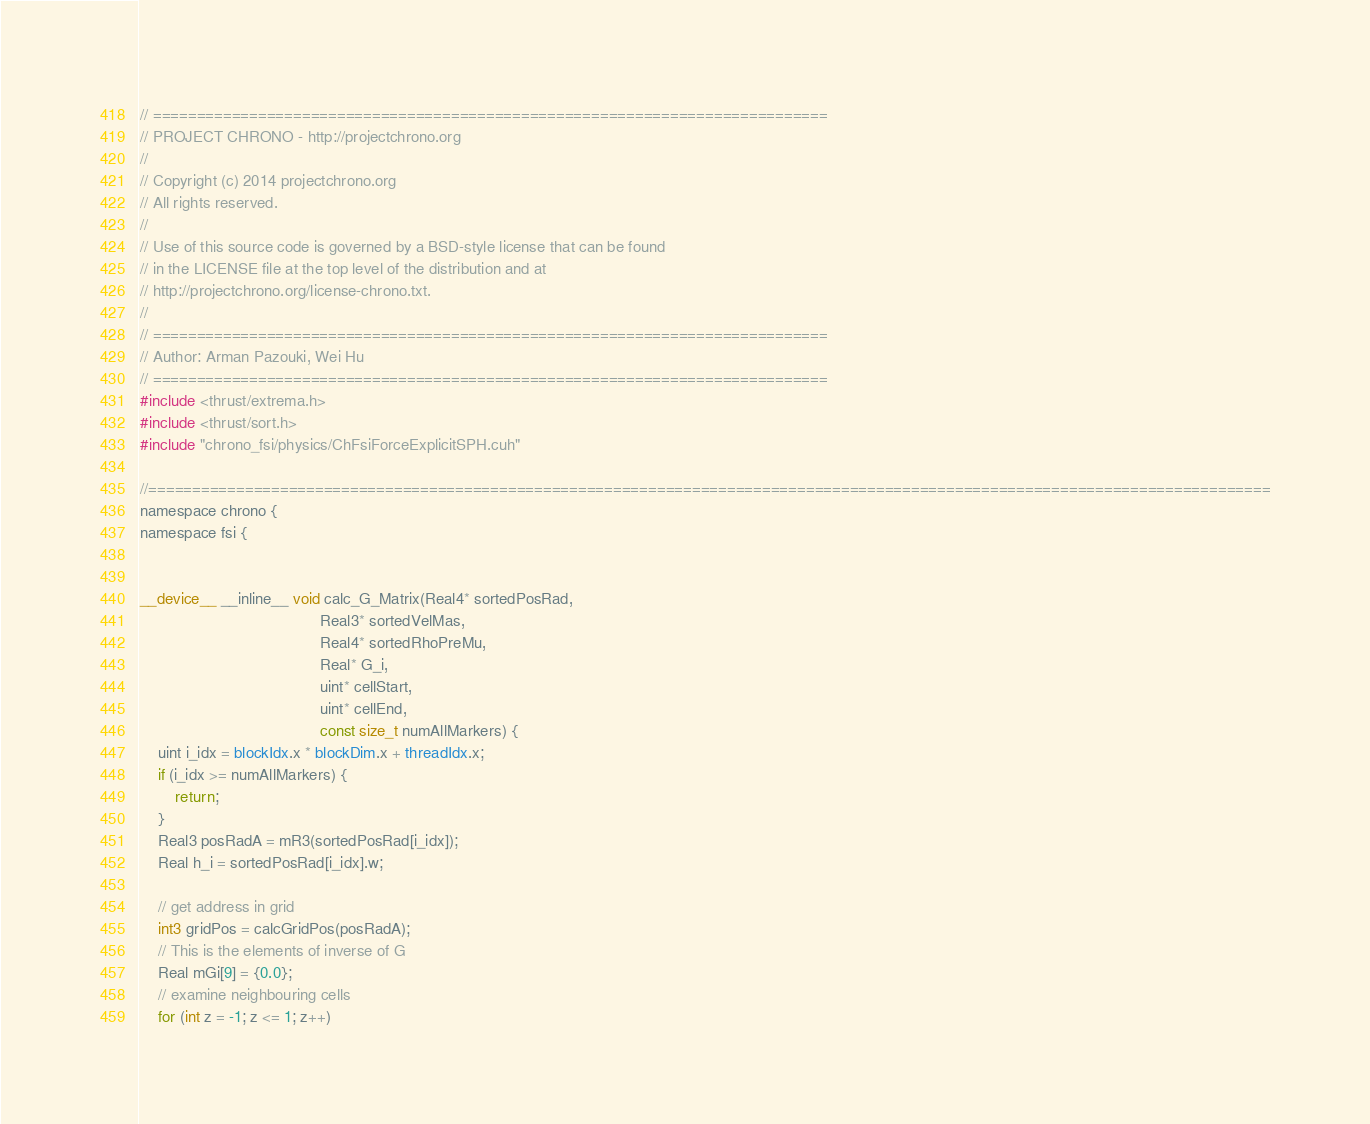<code> <loc_0><loc_0><loc_500><loc_500><_Cuda_>// =============================================================================
// PROJECT CHRONO - http://projectchrono.org
//
// Copyright (c) 2014 projectchrono.org
// All rights reserved.
//
// Use of this source code is governed by a BSD-style license that can be found
// in the LICENSE file at the top level of the distribution and at
// http://projectchrono.org/license-chrono.txt.
//
// =============================================================================
// Author: Arman Pazouki, Wei Hu
// =============================================================================
#include <thrust/extrema.h>
#include <thrust/sort.h>
#include "chrono_fsi/physics/ChFsiForceExplicitSPH.cuh"

//================================================================================================================================
namespace chrono {
namespace fsi {


__device__ __inline__ void calc_G_Matrix(Real4* sortedPosRad,
                                         Real3* sortedVelMas,
                                         Real4* sortedRhoPreMu,
                                         Real* G_i,
                                         uint* cellStart,
                                         uint* cellEnd,
                                         const size_t numAllMarkers) {
    uint i_idx = blockIdx.x * blockDim.x + threadIdx.x;
    if (i_idx >= numAllMarkers) {
        return;
    }
    Real3 posRadA = mR3(sortedPosRad[i_idx]);
    Real h_i = sortedPosRad[i_idx].w;

    // get address in grid
    int3 gridPos = calcGridPos(posRadA);
    // This is the elements of inverse of G
    Real mGi[9] = {0.0};
    // examine neighbouring cells
    for (int z = -1; z <= 1; z++)</code> 